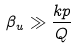Convert formula to latex. <formula><loc_0><loc_0><loc_500><loc_500>\beta _ { u } \gg \frac { k p } { Q }</formula> 